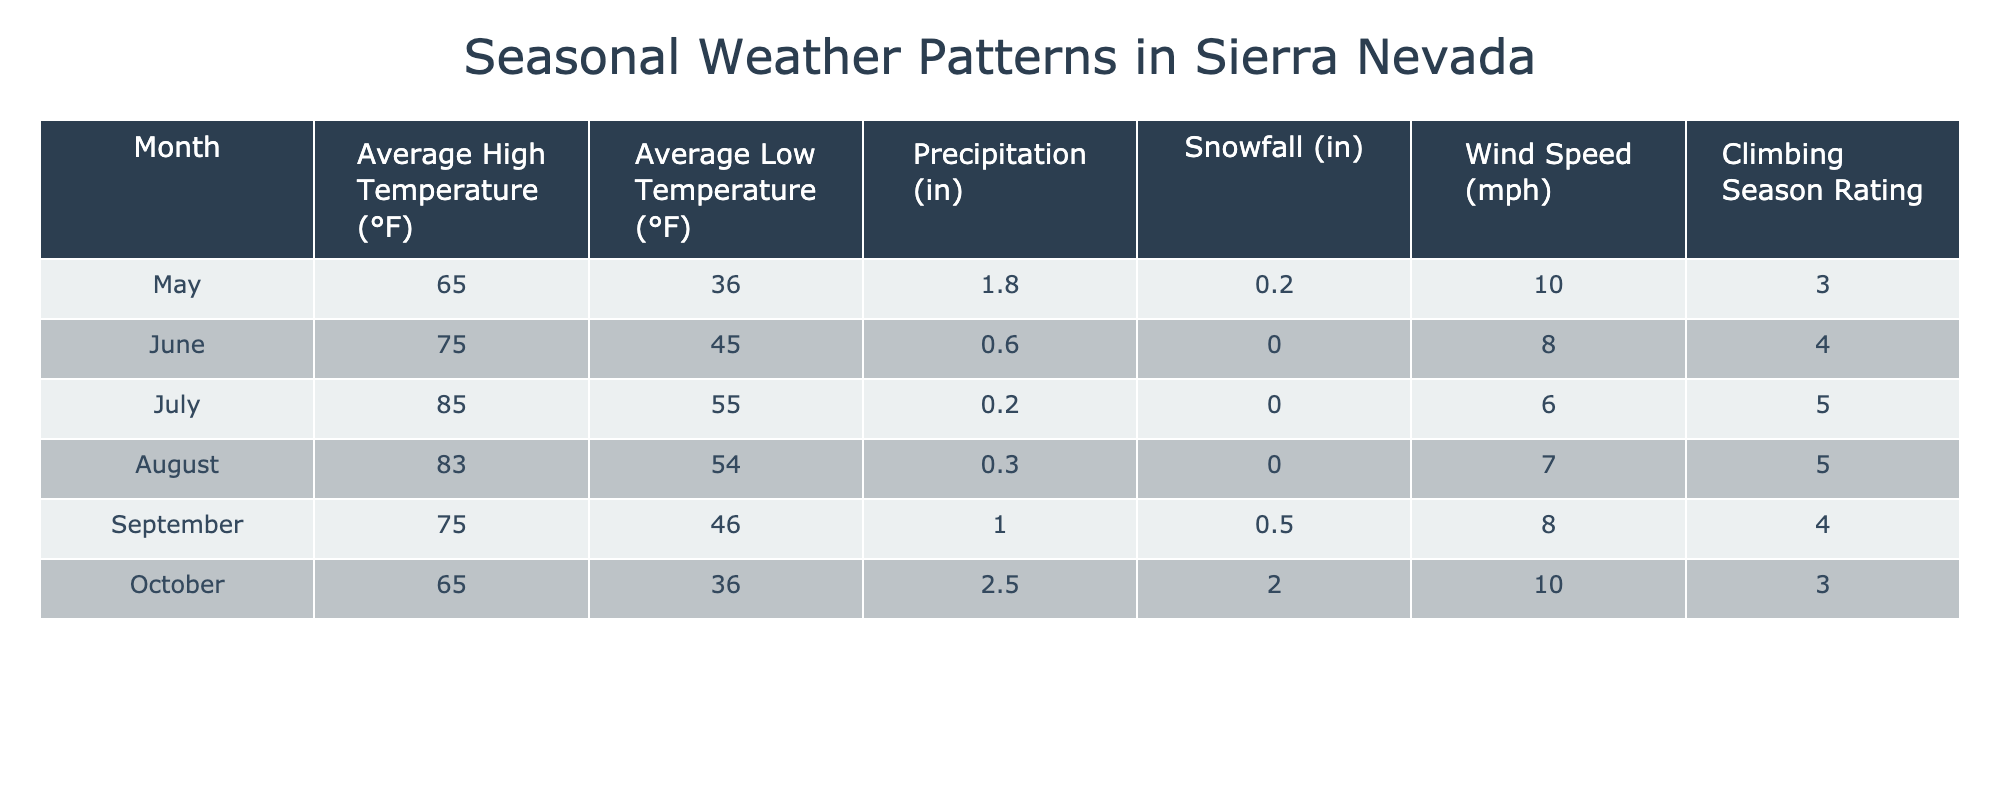What is the average high temperature in July? The table shows that the average high temperature for July is listed directly under that month. It states 85°F.
Answer: 85°F Which month has the lowest average low temperature? By checking the "Average Low Temperature (°F)" column, May and October have identical low temperatures of 36°F. However, May is earlier in the climbing season, making it effectively lower in the context of optimal climbing months.
Answer: May What is the total snowfall recorded in the climbing months from June to September? The snowfall amounts for each of those months are: June (0.0 in), July (0.0 in), August (0.0 in), and September (0.5 in). Adding these yields 0 + 0 + 0 + 0.5 = 0.5 inches of snowfall.
Answer: 0.5 inches Is it true that August has a higher average high temperature than June? Looking at the "Average High Temperature (°F)" column, August has a temperature of 83°F, whereas June has 75°F. Since 83 is greater than 75, the statement is true.
Answer: Yes Which month has the least precipitation? From the "Precipitation (in)" column, July has the least amount at 0.2 inches, which is less than any other month's precipitation listed in the table.
Answer: July What is the range of average low temperatures from May to September? To find the range, identify the highest and lowest average low temperatures in the given months: May (36°F) and September (46°F). The range is calculated as 46°F - 36°F = 10°F.
Answer: 10°F Which month has the highest climbing season rating? By reviewing the "Climbing Season Rating" column, July and August both have a rating of 5, which is the highest among all the months listed.
Answer: July and August What is the average wind speed during the months of October and May? The wind speed for October is 10 mph and for May is 10 mph. To find the average: (10 + 10) / 2 = 10 mph.
Answer: 10 mph 